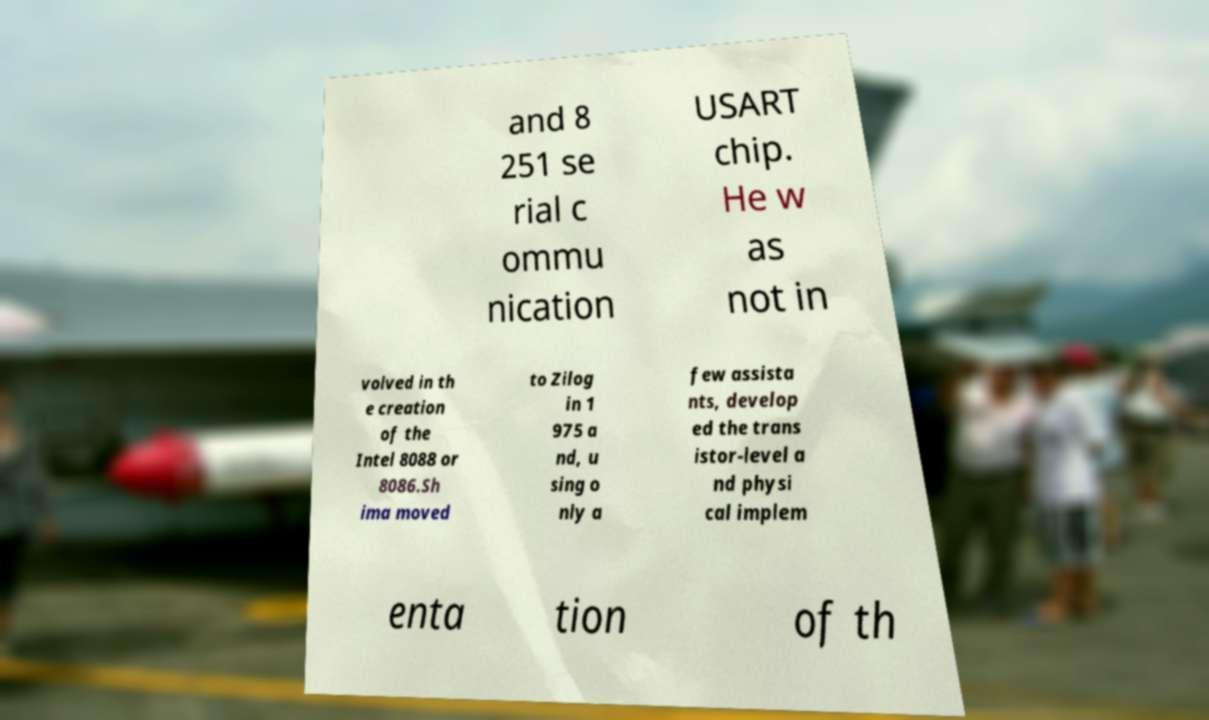Can you read and provide the text displayed in the image?This photo seems to have some interesting text. Can you extract and type it out for me? and 8 251 se rial c ommu nication USART chip. He w as not in volved in th e creation of the Intel 8088 or 8086.Sh ima moved to Zilog in 1 975 a nd, u sing o nly a few assista nts, develop ed the trans istor-level a nd physi cal implem enta tion of th 